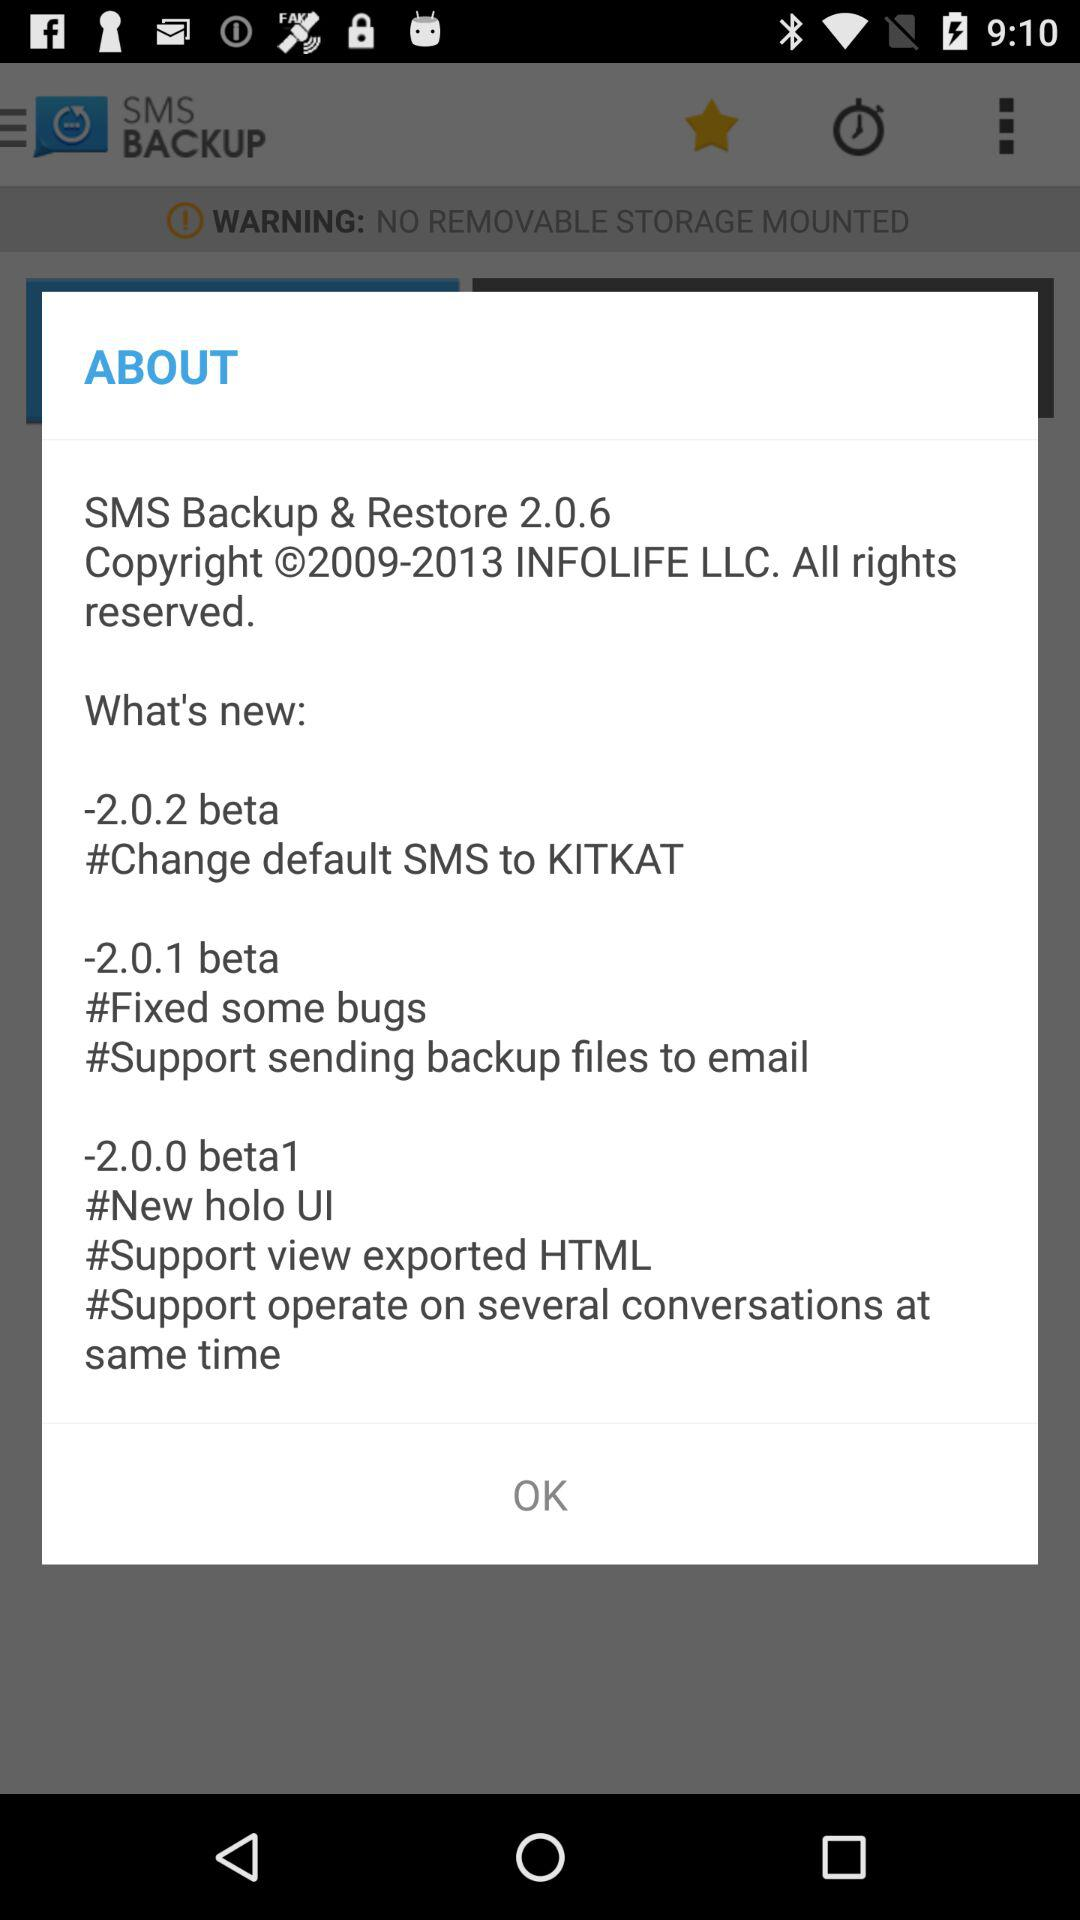How many beta versions are mentioned in the changelog?
Answer the question using a single word or phrase. 3 